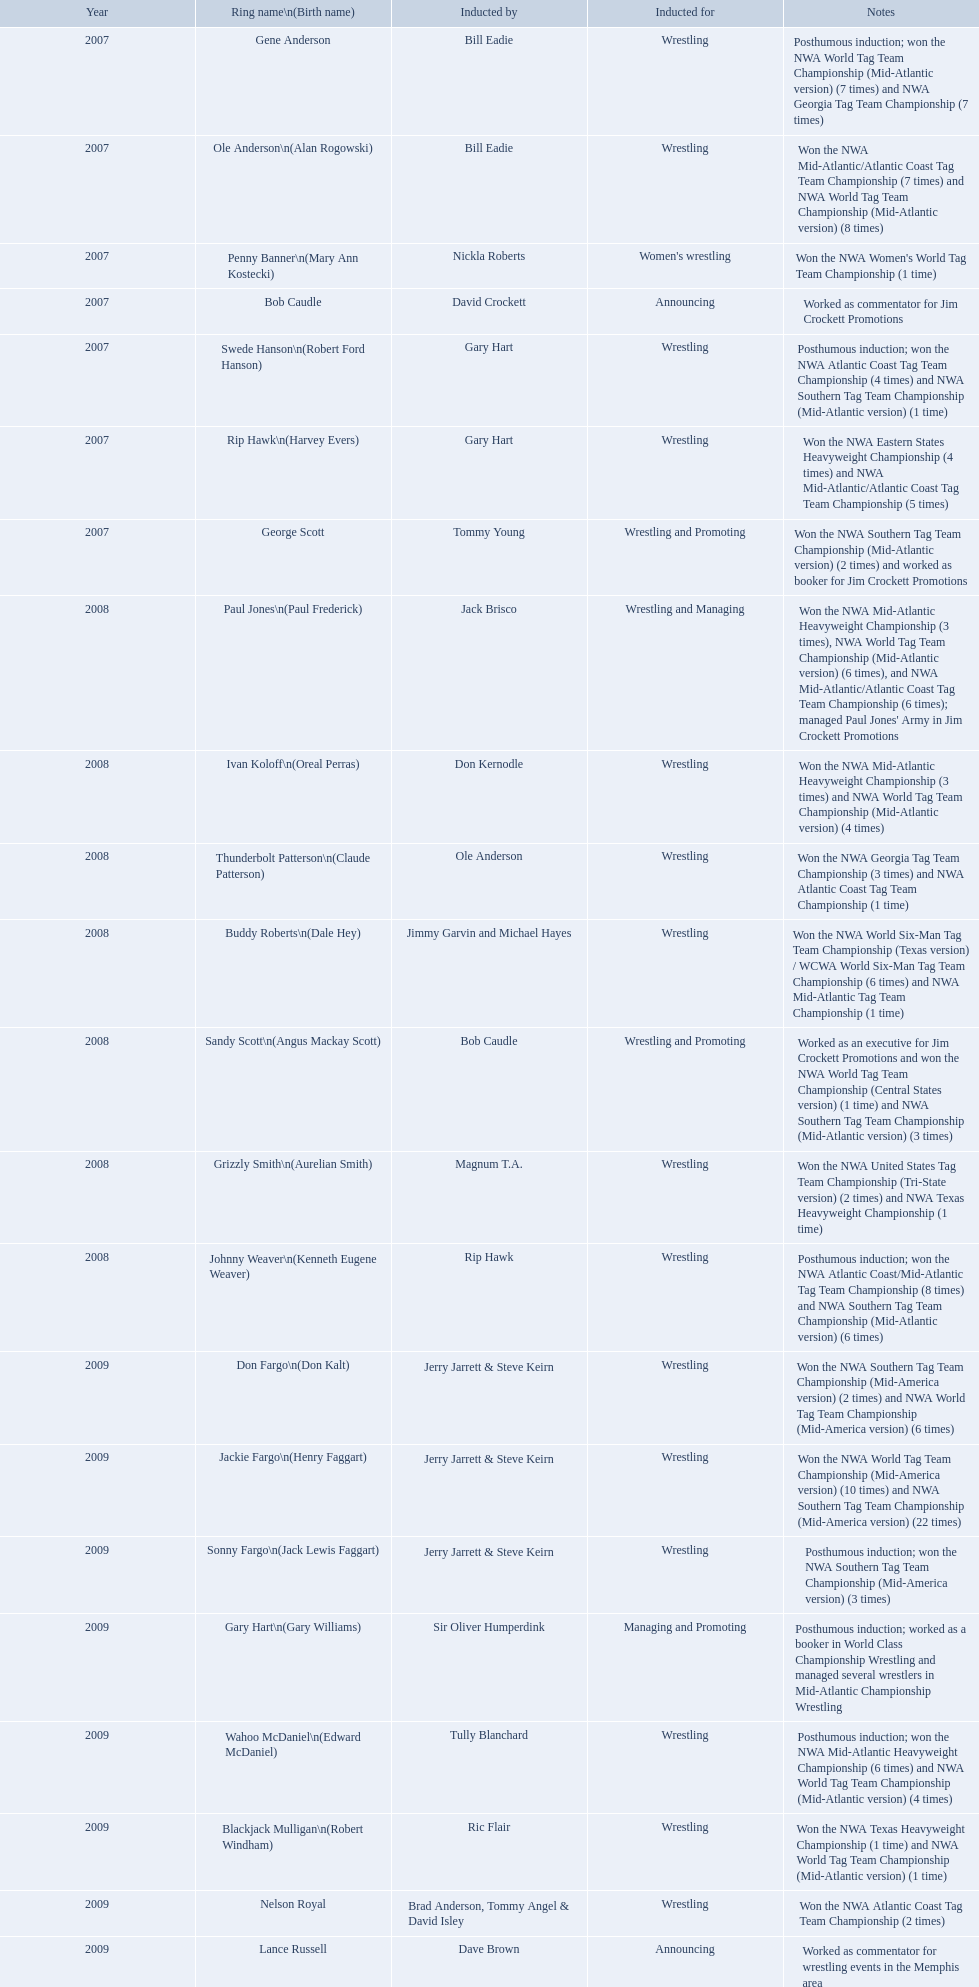What were the names of the inductees in 2007? Gene Anderson, Ole Anderson\n(Alan Rogowski), Penny Banner\n(Mary Ann Kostecki), Bob Caudle, Swede Hanson\n(Robert Ford Hanson), Rip Hawk\n(Harvey Evers), George Scott. Of the 2007 inductees, which were posthumous? Gene Anderson, Swede Hanson\n(Robert Ford Hanson). Besides swede hanson, what other 2007 inductee was not living at the time of induction? Gene Anderson. What were all the wrestler's ring names? Gene Anderson, Ole Anderson\n(Alan Rogowski), Penny Banner\n(Mary Ann Kostecki), Bob Caudle, Swede Hanson\n(Robert Ford Hanson), Rip Hawk\n(Harvey Evers), George Scott, Paul Jones\n(Paul Frederick), Ivan Koloff\n(Oreal Perras), Thunderbolt Patterson\n(Claude Patterson), Buddy Roberts\n(Dale Hey), Sandy Scott\n(Angus Mackay Scott), Grizzly Smith\n(Aurelian Smith), Johnny Weaver\n(Kenneth Eugene Weaver), Don Fargo\n(Don Kalt), Jackie Fargo\n(Henry Faggart), Sonny Fargo\n(Jack Lewis Faggart), Gary Hart\n(Gary Williams), Wahoo McDaniel\n(Edward McDaniel), Blackjack Mulligan\n(Robert Windham), Nelson Royal, Lance Russell. Besides bob caudle, who was an announcer? Lance Russell. Could you help me parse every detail presented in this table? {'header': ['Year', 'Ring name\\n(Birth name)', 'Inducted by', 'Inducted for', 'Notes'], 'rows': [['2007', 'Gene Anderson', 'Bill Eadie', 'Wrestling', 'Posthumous induction; won the NWA World Tag Team Championship (Mid-Atlantic version) (7 times) and NWA Georgia Tag Team Championship (7 times)'], ['2007', 'Ole Anderson\\n(Alan Rogowski)', 'Bill Eadie', 'Wrestling', 'Won the NWA Mid-Atlantic/Atlantic Coast Tag Team Championship (7 times) and NWA World Tag Team Championship (Mid-Atlantic version) (8 times)'], ['2007', 'Penny Banner\\n(Mary Ann Kostecki)', 'Nickla Roberts', "Women's wrestling", "Won the NWA Women's World Tag Team Championship (1 time)"], ['2007', 'Bob Caudle', 'David Crockett', 'Announcing', 'Worked as commentator for Jim Crockett Promotions'], ['2007', 'Swede Hanson\\n(Robert Ford Hanson)', 'Gary Hart', 'Wrestling', 'Posthumous induction; won the NWA Atlantic Coast Tag Team Championship (4 times) and NWA Southern Tag Team Championship (Mid-Atlantic version) (1 time)'], ['2007', 'Rip Hawk\\n(Harvey Evers)', 'Gary Hart', 'Wrestling', 'Won the NWA Eastern States Heavyweight Championship (4 times) and NWA Mid-Atlantic/Atlantic Coast Tag Team Championship (5 times)'], ['2007', 'George Scott', 'Tommy Young', 'Wrestling and Promoting', 'Won the NWA Southern Tag Team Championship (Mid-Atlantic version) (2 times) and worked as booker for Jim Crockett Promotions'], ['2008', 'Paul Jones\\n(Paul Frederick)', 'Jack Brisco', 'Wrestling and Managing', "Won the NWA Mid-Atlantic Heavyweight Championship (3 times), NWA World Tag Team Championship (Mid-Atlantic version) (6 times), and NWA Mid-Atlantic/Atlantic Coast Tag Team Championship (6 times); managed Paul Jones' Army in Jim Crockett Promotions"], ['2008', 'Ivan Koloff\\n(Oreal Perras)', 'Don Kernodle', 'Wrestling', 'Won the NWA Mid-Atlantic Heavyweight Championship (3 times) and NWA World Tag Team Championship (Mid-Atlantic version) (4 times)'], ['2008', 'Thunderbolt Patterson\\n(Claude Patterson)', 'Ole Anderson', 'Wrestling', 'Won the NWA Georgia Tag Team Championship (3 times) and NWA Atlantic Coast Tag Team Championship (1 time)'], ['2008', 'Buddy Roberts\\n(Dale Hey)', 'Jimmy Garvin and Michael Hayes', 'Wrestling', 'Won the NWA World Six-Man Tag Team Championship (Texas version) / WCWA World Six-Man Tag Team Championship (6 times) and NWA Mid-Atlantic Tag Team Championship (1 time)'], ['2008', 'Sandy Scott\\n(Angus Mackay Scott)', 'Bob Caudle', 'Wrestling and Promoting', 'Worked as an executive for Jim Crockett Promotions and won the NWA World Tag Team Championship (Central States version) (1 time) and NWA Southern Tag Team Championship (Mid-Atlantic version) (3 times)'], ['2008', 'Grizzly Smith\\n(Aurelian Smith)', 'Magnum T.A.', 'Wrestling', 'Won the NWA United States Tag Team Championship (Tri-State version) (2 times) and NWA Texas Heavyweight Championship (1 time)'], ['2008', 'Johnny Weaver\\n(Kenneth Eugene Weaver)', 'Rip Hawk', 'Wrestling', 'Posthumous induction; won the NWA Atlantic Coast/Mid-Atlantic Tag Team Championship (8 times) and NWA Southern Tag Team Championship (Mid-Atlantic version) (6 times)'], ['2009', 'Don Fargo\\n(Don Kalt)', 'Jerry Jarrett & Steve Keirn', 'Wrestling', 'Won the NWA Southern Tag Team Championship (Mid-America version) (2 times) and NWA World Tag Team Championship (Mid-America version) (6 times)'], ['2009', 'Jackie Fargo\\n(Henry Faggart)', 'Jerry Jarrett & Steve Keirn', 'Wrestling', 'Won the NWA World Tag Team Championship (Mid-America version) (10 times) and NWA Southern Tag Team Championship (Mid-America version) (22 times)'], ['2009', 'Sonny Fargo\\n(Jack Lewis Faggart)', 'Jerry Jarrett & Steve Keirn', 'Wrestling', 'Posthumous induction; won the NWA Southern Tag Team Championship (Mid-America version) (3 times)'], ['2009', 'Gary Hart\\n(Gary Williams)', 'Sir Oliver Humperdink', 'Managing and Promoting', 'Posthumous induction; worked as a booker in World Class Championship Wrestling and managed several wrestlers in Mid-Atlantic Championship Wrestling'], ['2009', 'Wahoo McDaniel\\n(Edward McDaniel)', 'Tully Blanchard', 'Wrestling', 'Posthumous induction; won the NWA Mid-Atlantic Heavyweight Championship (6 times) and NWA World Tag Team Championship (Mid-Atlantic version) (4 times)'], ['2009', 'Blackjack Mulligan\\n(Robert Windham)', 'Ric Flair', 'Wrestling', 'Won the NWA Texas Heavyweight Championship (1 time) and NWA World Tag Team Championship (Mid-Atlantic version) (1 time)'], ['2009', 'Nelson Royal', 'Brad Anderson, Tommy Angel & David Isley', 'Wrestling', 'Won the NWA Atlantic Coast Tag Team Championship (2 times)'], ['2009', 'Lance Russell', 'Dave Brown', 'Announcing', 'Worked as commentator for wrestling events in the Memphis area']]} In 2007, which announcer was inducted into the hall of heroes? Bob Caudle. Can you give me this table in json format? {'header': ['Year', 'Ring name\\n(Birth name)', 'Inducted by', 'Inducted for', 'Notes'], 'rows': [['2007', 'Gene Anderson', 'Bill Eadie', 'Wrestling', 'Posthumous induction; won the NWA World Tag Team Championship (Mid-Atlantic version) (7 times) and NWA Georgia Tag Team Championship (7 times)'], ['2007', 'Ole Anderson\\n(Alan Rogowski)', 'Bill Eadie', 'Wrestling', 'Won the NWA Mid-Atlantic/Atlantic Coast Tag Team Championship (7 times) and NWA World Tag Team Championship (Mid-Atlantic version) (8 times)'], ['2007', 'Penny Banner\\n(Mary Ann Kostecki)', 'Nickla Roberts', "Women's wrestling", "Won the NWA Women's World Tag Team Championship (1 time)"], ['2007', 'Bob Caudle', 'David Crockett', 'Announcing', 'Worked as commentator for Jim Crockett Promotions'], ['2007', 'Swede Hanson\\n(Robert Ford Hanson)', 'Gary Hart', 'Wrestling', 'Posthumous induction; won the NWA Atlantic Coast Tag Team Championship (4 times) and NWA Southern Tag Team Championship (Mid-Atlantic version) (1 time)'], ['2007', 'Rip Hawk\\n(Harvey Evers)', 'Gary Hart', 'Wrestling', 'Won the NWA Eastern States Heavyweight Championship (4 times) and NWA Mid-Atlantic/Atlantic Coast Tag Team Championship (5 times)'], ['2007', 'George Scott', 'Tommy Young', 'Wrestling and Promoting', 'Won the NWA Southern Tag Team Championship (Mid-Atlantic version) (2 times) and worked as booker for Jim Crockett Promotions'], ['2008', 'Paul Jones\\n(Paul Frederick)', 'Jack Brisco', 'Wrestling and Managing', "Won the NWA Mid-Atlantic Heavyweight Championship (3 times), NWA World Tag Team Championship (Mid-Atlantic version) (6 times), and NWA Mid-Atlantic/Atlantic Coast Tag Team Championship (6 times); managed Paul Jones' Army in Jim Crockett Promotions"], ['2008', 'Ivan Koloff\\n(Oreal Perras)', 'Don Kernodle', 'Wrestling', 'Won the NWA Mid-Atlantic Heavyweight Championship (3 times) and NWA World Tag Team Championship (Mid-Atlantic version) (4 times)'], ['2008', 'Thunderbolt Patterson\\n(Claude Patterson)', 'Ole Anderson', 'Wrestling', 'Won the NWA Georgia Tag Team Championship (3 times) and NWA Atlantic Coast Tag Team Championship (1 time)'], ['2008', 'Buddy Roberts\\n(Dale Hey)', 'Jimmy Garvin and Michael Hayes', 'Wrestling', 'Won the NWA World Six-Man Tag Team Championship (Texas version) / WCWA World Six-Man Tag Team Championship (6 times) and NWA Mid-Atlantic Tag Team Championship (1 time)'], ['2008', 'Sandy Scott\\n(Angus Mackay Scott)', 'Bob Caudle', 'Wrestling and Promoting', 'Worked as an executive for Jim Crockett Promotions and won the NWA World Tag Team Championship (Central States version) (1 time) and NWA Southern Tag Team Championship (Mid-Atlantic version) (3 times)'], ['2008', 'Grizzly Smith\\n(Aurelian Smith)', 'Magnum T.A.', 'Wrestling', 'Won the NWA United States Tag Team Championship (Tri-State version) (2 times) and NWA Texas Heavyweight Championship (1 time)'], ['2008', 'Johnny Weaver\\n(Kenneth Eugene Weaver)', 'Rip Hawk', 'Wrestling', 'Posthumous induction; won the NWA Atlantic Coast/Mid-Atlantic Tag Team Championship (8 times) and NWA Southern Tag Team Championship (Mid-Atlantic version) (6 times)'], ['2009', 'Don Fargo\\n(Don Kalt)', 'Jerry Jarrett & Steve Keirn', 'Wrestling', 'Won the NWA Southern Tag Team Championship (Mid-America version) (2 times) and NWA World Tag Team Championship (Mid-America version) (6 times)'], ['2009', 'Jackie Fargo\\n(Henry Faggart)', 'Jerry Jarrett & Steve Keirn', 'Wrestling', 'Won the NWA World Tag Team Championship (Mid-America version) (10 times) and NWA Southern Tag Team Championship (Mid-America version) (22 times)'], ['2009', 'Sonny Fargo\\n(Jack Lewis Faggart)', 'Jerry Jarrett & Steve Keirn', 'Wrestling', 'Posthumous induction; won the NWA Southern Tag Team Championship (Mid-America version) (3 times)'], ['2009', 'Gary Hart\\n(Gary Williams)', 'Sir Oliver Humperdink', 'Managing and Promoting', 'Posthumous induction; worked as a booker in World Class Championship Wrestling and managed several wrestlers in Mid-Atlantic Championship Wrestling'], ['2009', 'Wahoo McDaniel\\n(Edward McDaniel)', 'Tully Blanchard', 'Wrestling', 'Posthumous induction; won the NWA Mid-Atlantic Heavyweight Championship (6 times) and NWA World Tag Team Championship (Mid-Atlantic version) (4 times)'], ['2009', 'Blackjack Mulligan\\n(Robert Windham)', 'Ric Flair', 'Wrestling', 'Won the NWA Texas Heavyweight Championship (1 time) and NWA World Tag Team Championship (Mid-Atlantic version) (1 time)'], ['2009', 'Nelson Royal', 'Brad Anderson, Tommy Angel & David Isley', 'Wrestling', 'Won the NWA Atlantic Coast Tag Team Championship (2 times)'], ['2009', 'Lance Russell', 'Dave Brown', 'Announcing', 'Worked as commentator for wrestling events in the Memphis area']]} Who was the next announcer that got inducted? Lance Russell. What were all the wrestler's alias names? Gene Anderson, Ole Anderson\n(Alan Rogowski), Penny Banner\n(Mary Ann Kostecki), Bob Caudle, Swede Hanson\n(Robert Ford Hanson), Rip Hawk\n(Harvey Evers), George Scott, Paul Jones\n(Paul Frederick), Ivan Koloff\n(Oreal Perras), Thunderbolt Patterson\n(Claude Patterson), Buddy Roberts\n(Dale Hey), Sandy Scott\n(Angus Mackay Scott), Grizzly Smith\n(Aurelian Smith), Johnny Weaver\n(Kenneth Eugene Weaver), Don Fargo\n(Don Kalt), Jackie Fargo\n(Henry Faggart), Sonny Fargo\n(Jack Lewis Faggart), Gary Hart\n(Gary Williams), Wahoo McDaniel\n(Edward McDaniel), Blackjack Mulligan\n(Robert Windham), Nelson Royal, Lance Russell. Other than bob caudle, who functioned as a commentator? Lance Russell. In which year did the induction occur? 2007. Which inductee had already passed away? Gene Anderson. Which announcers have been inducted? Bob Caudle, Lance Russell. Who was the announcer inducted in 2009? Lance Russell. Can you name the inducted announcers? Bob Caudle, Lance Russell. Who was the 2009 inductee as an announcer? Lance Russell. 